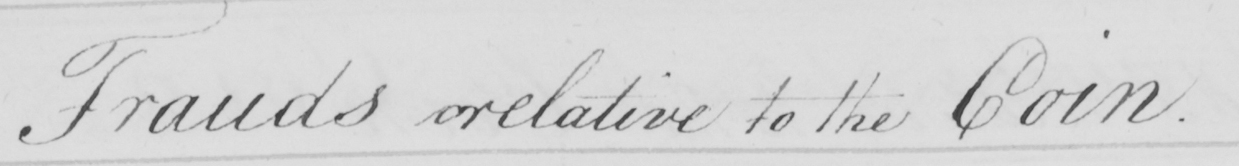Transcribe the text shown in this historical manuscript line. Frauds relative to the Coin . 